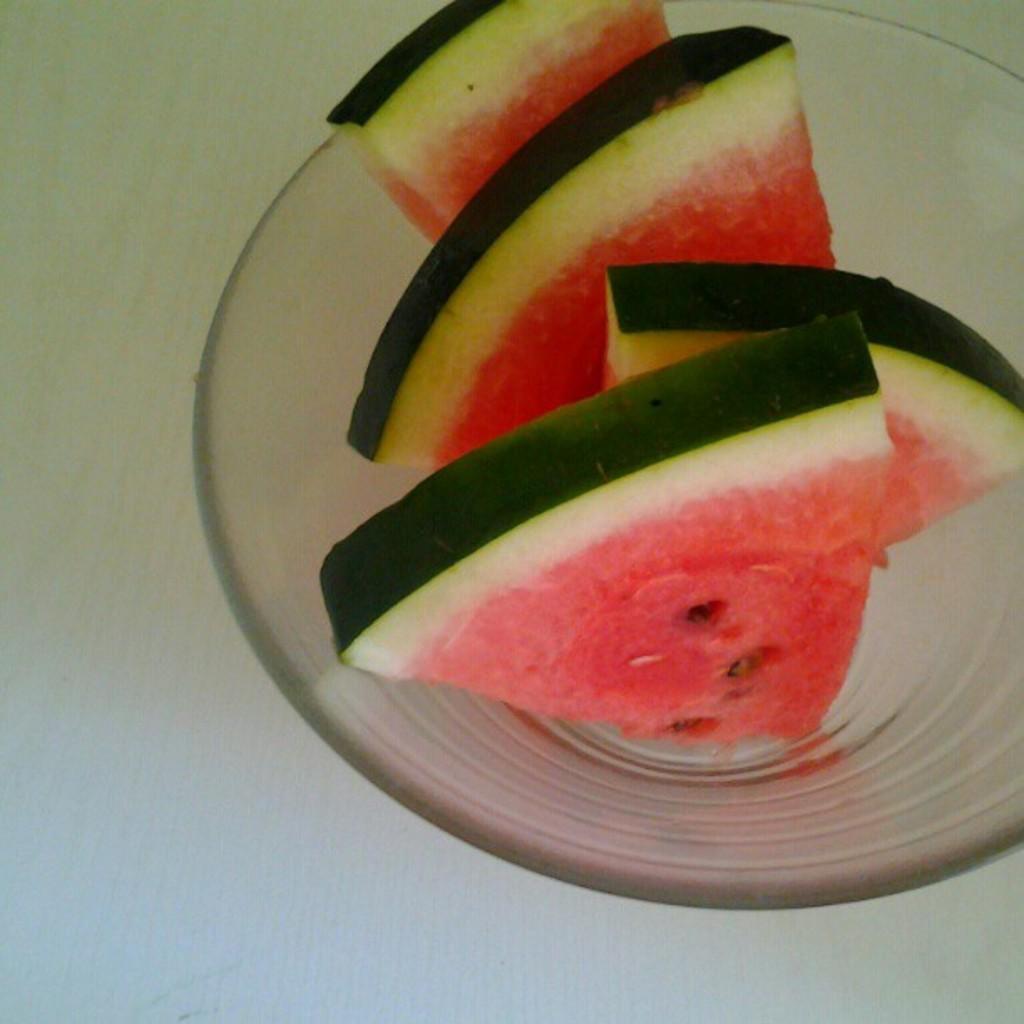In one or two sentences, can you explain what this image depicts? In this picture we can see a bowl on the surface with watermelon pieces in it. 